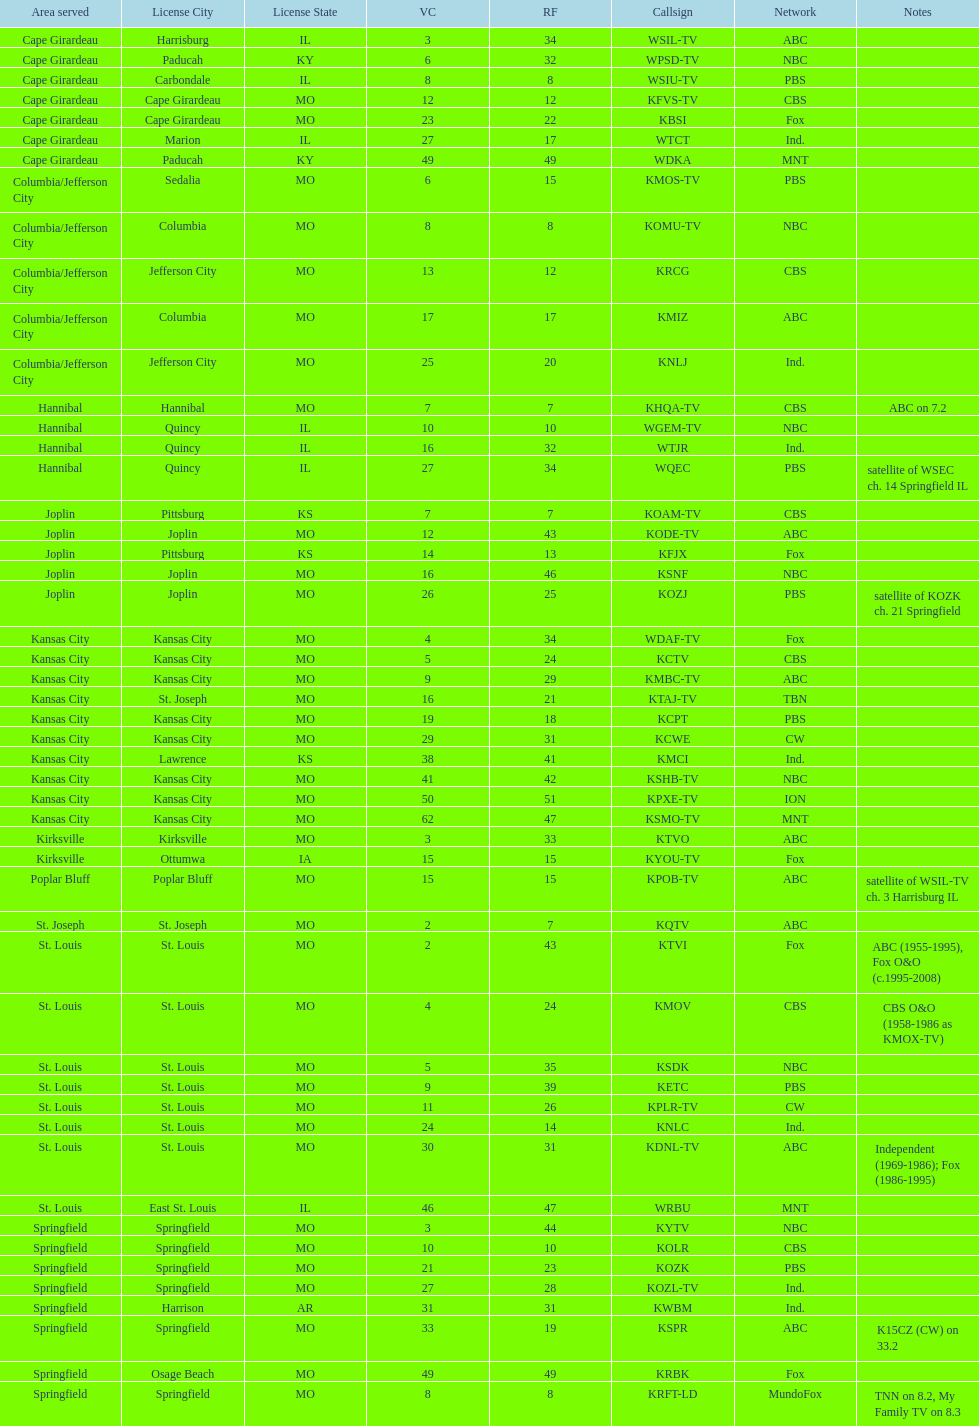How many areas have at least 5 stations? 6. 